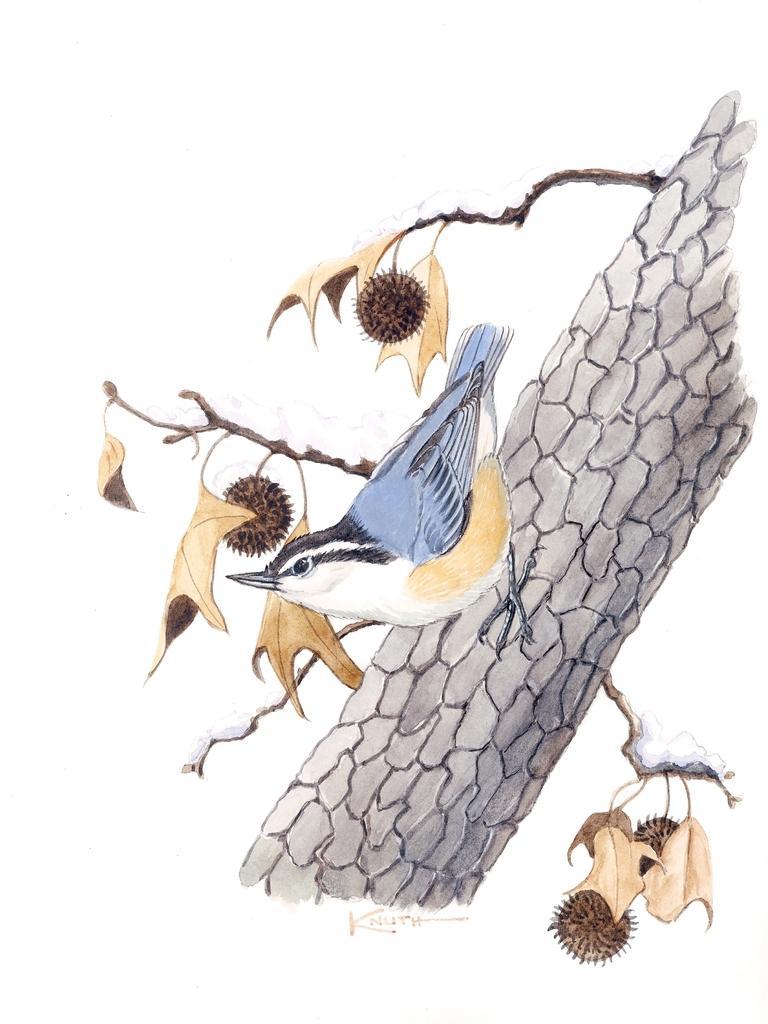Can you describe this image briefly? This looks like a painting. There is a tree and there is a bird on that tree. 